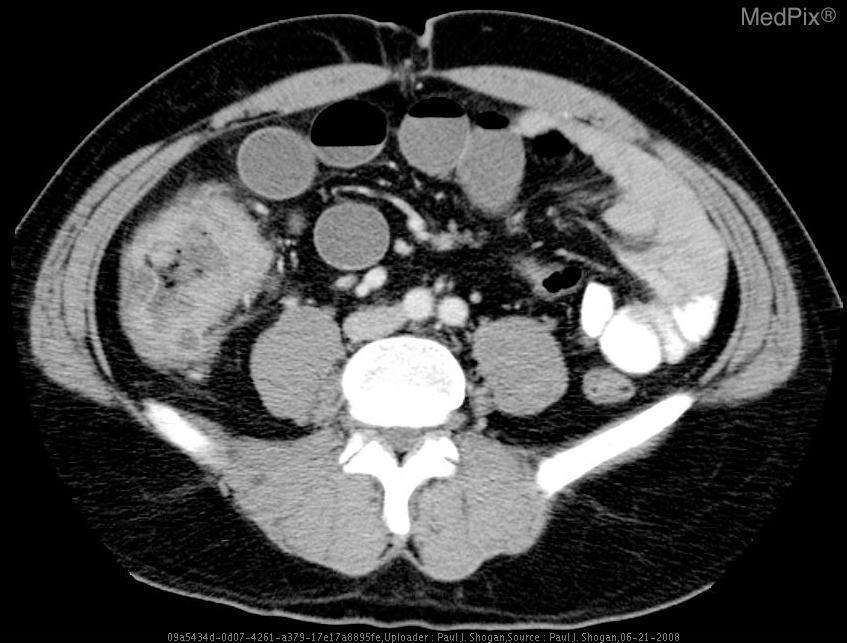Are there air fluid levels?
Write a very short answer. Yes. Is there a bowel obstrution
Give a very brief answer. Yes. Is the bowel obstructed?
Short answer required. Yes. What is the location of the mass?
Keep it brief. Cecum. Where is the mass?
Quick response, please. Cecum. Is the bowel dilated?
Keep it brief. Yes. Is there dilation of the bowel?
Keep it brief. Yes. 